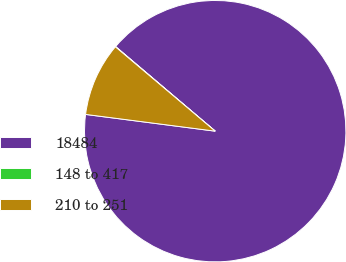Convert chart. <chart><loc_0><loc_0><loc_500><loc_500><pie_chart><fcel>18484<fcel>148 to 417<fcel>210 to 251<nl><fcel>90.84%<fcel>0.04%<fcel>9.12%<nl></chart> 